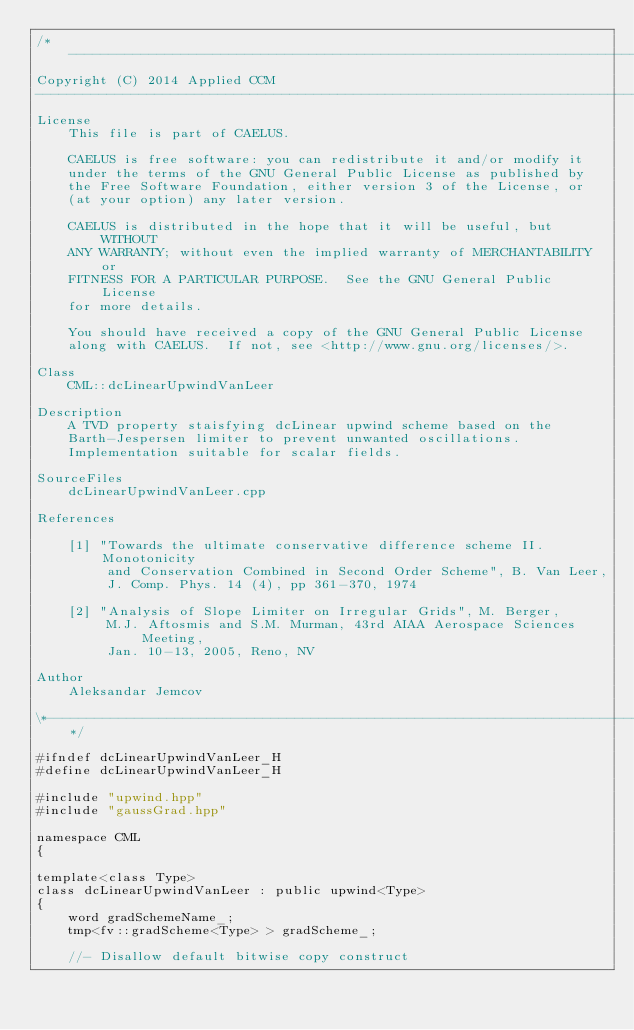Convert code to text. <code><loc_0><loc_0><loc_500><loc_500><_C++_>/*---------------------------------------------------------------------------*\
Copyright (C) 2014 Applied CCM
-------------------------------------------------------------------------------
License
    This file is part of CAELUS.

    CAELUS is free software: you can redistribute it and/or modify it
    under the terms of the GNU General Public License as published by
    the Free Software Foundation, either version 3 of the License, or
    (at your option) any later version.

    CAELUS is distributed in the hope that it will be useful, but WITHOUT
    ANY WARRANTY; without even the implied warranty of MERCHANTABILITY or
    FITNESS FOR A PARTICULAR PURPOSE.  See the GNU General Public License
    for more details.

    You should have received a copy of the GNU General Public License
    along with CAELUS.  If not, see <http://www.gnu.org/licenses/>.

Class
    CML::dcLinearUpwindVanLeer

Description
    A TVD property staisfying dcLinear upwind scheme based on the 
    Barth-Jespersen limiter to prevent unwanted oscillations. 
    Implementation suitable for scalar fields.

SourceFiles
    dcLinearUpwindVanLeer.cpp

References

    [1] "Towards the ultimate conservative difference scheme II. Monotonicity 
         and Conservation Combined in Second Order Scheme", B. Van Leer,
         J. Comp. Phys. 14 (4), pp 361-370, 1974

    [2] "Analysis of Slope Limiter on Irregular Grids", M. Berger, 
         M.J. Aftosmis and S.M. Murman, 43rd AIAA Aerospace Sciences Meeting, 
         Jan. 10-13, 2005, Reno, NV

Author
    Aleksandar Jemcov

\*---------------------------------------------------------------------------*/

#ifndef dcLinearUpwindVanLeer_H
#define dcLinearUpwindVanLeer_H

#include "upwind.hpp"
#include "gaussGrad.hpp"

namespace CML
{

template<class Type>
class dcLinearUpwindVanLeer : public upwind<Type>
{
    word gradSchemeName_;
    tmp<fv::gradScheme<Type> > gradScheme_;

    //- Disallow default bitwise copy construct</code> 